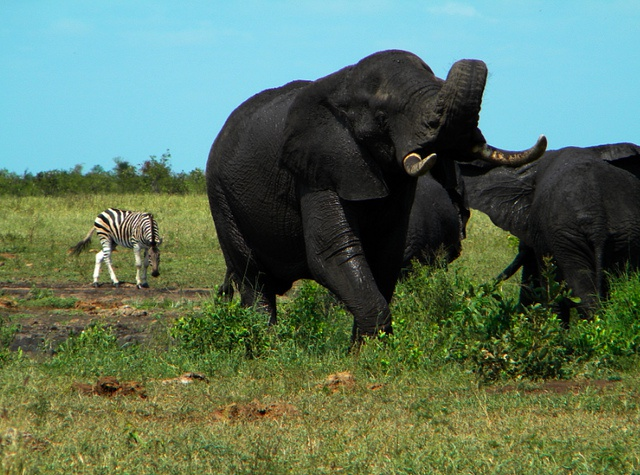Describe the objects in this image and their specific colors. I can see elephant in lightblue, black, darkgreen, and gray tones, elephant in lightblue, black, gray, and darkgreen tones, and zebra in lightblue, gray, black, darkgreen, and ivory tones in this image. 